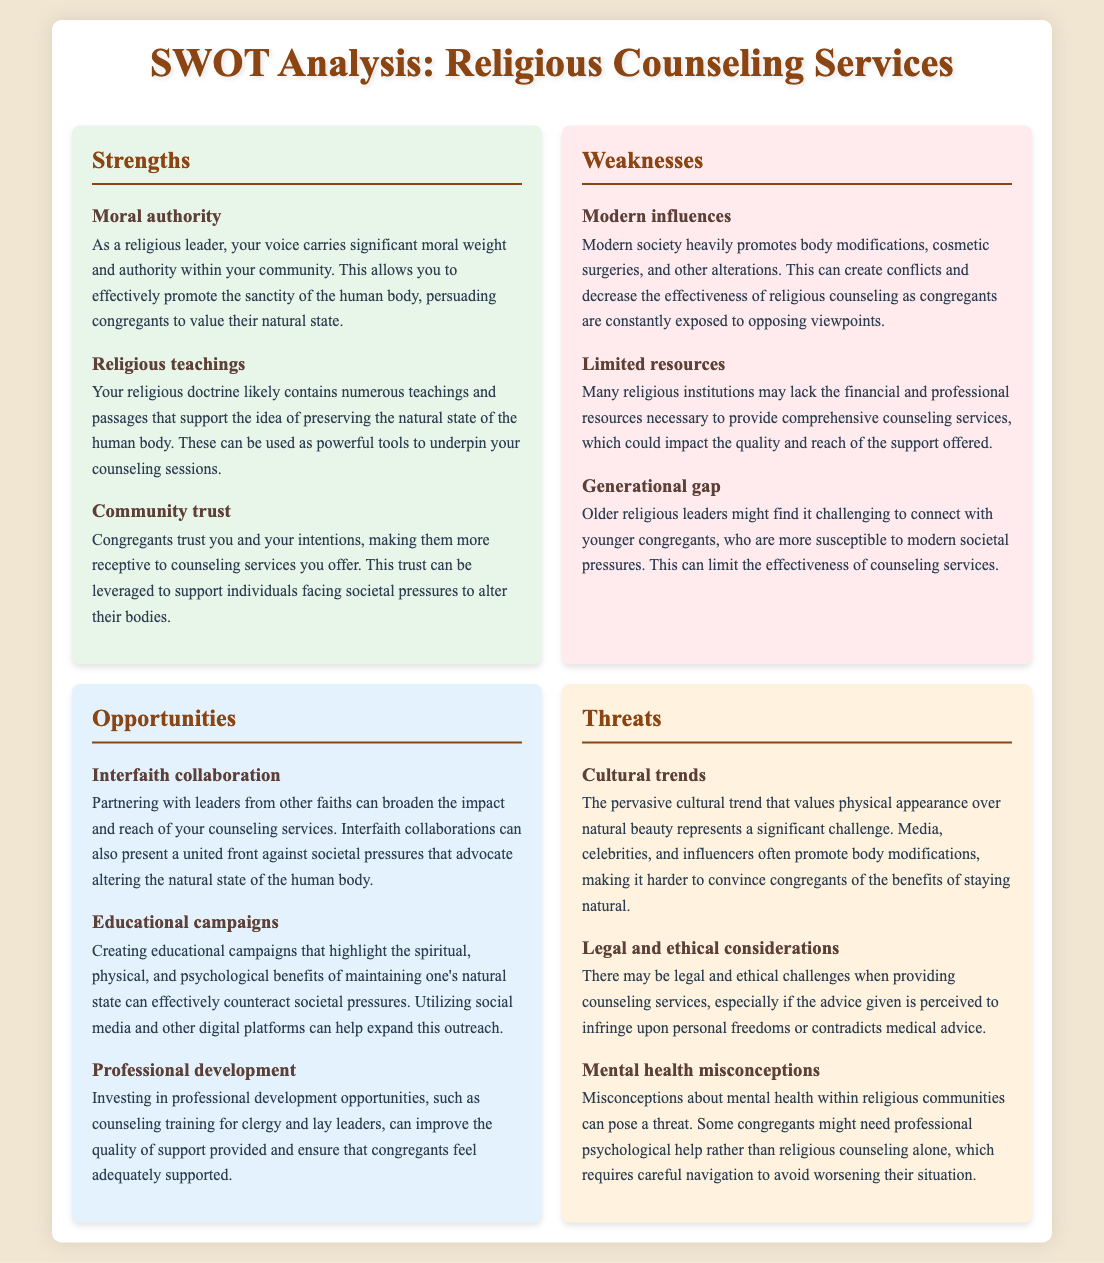What is the title of the document? The title is stated at the top of the document as "SWOT Analysis: Religious Counseling Services."
Answer: SWOT Analysis: Religious Counseling Services How many strengths are listed? The document lists three strengths in the SWOT analysis section.
Answer: 3 What is a key weakness mentioned? One of the weaknesses outlined is "Modern influences."
Answer: Modern influences What opportunity is highlighted? An opportunity mentioned is "Interfaith collaboration."
Answer: Interfaith collaboration What cultural challenge is identified as a threat? The document identifies "Cultural trends" as a significant threat.
Answer: Cultural trends What specific resource limitation is noted? The document notes "Limited resources" as a specific weakness.
Answer: Limited resources Which group is emphasized to have trust in the religious leader? The document mentions "Congregants" as the group that trusts the religious leader.
Answer: Congregants What type of campaigns can counteract societal pressures? "Educational campaigns" are suggested as a way to counter societal pressures.
Answer: Educational campaigns What misconception may pose a threat to counseling effectiveness? The misconception about "Mental health" within religious communities poses a threat.
Answer: Mental health 